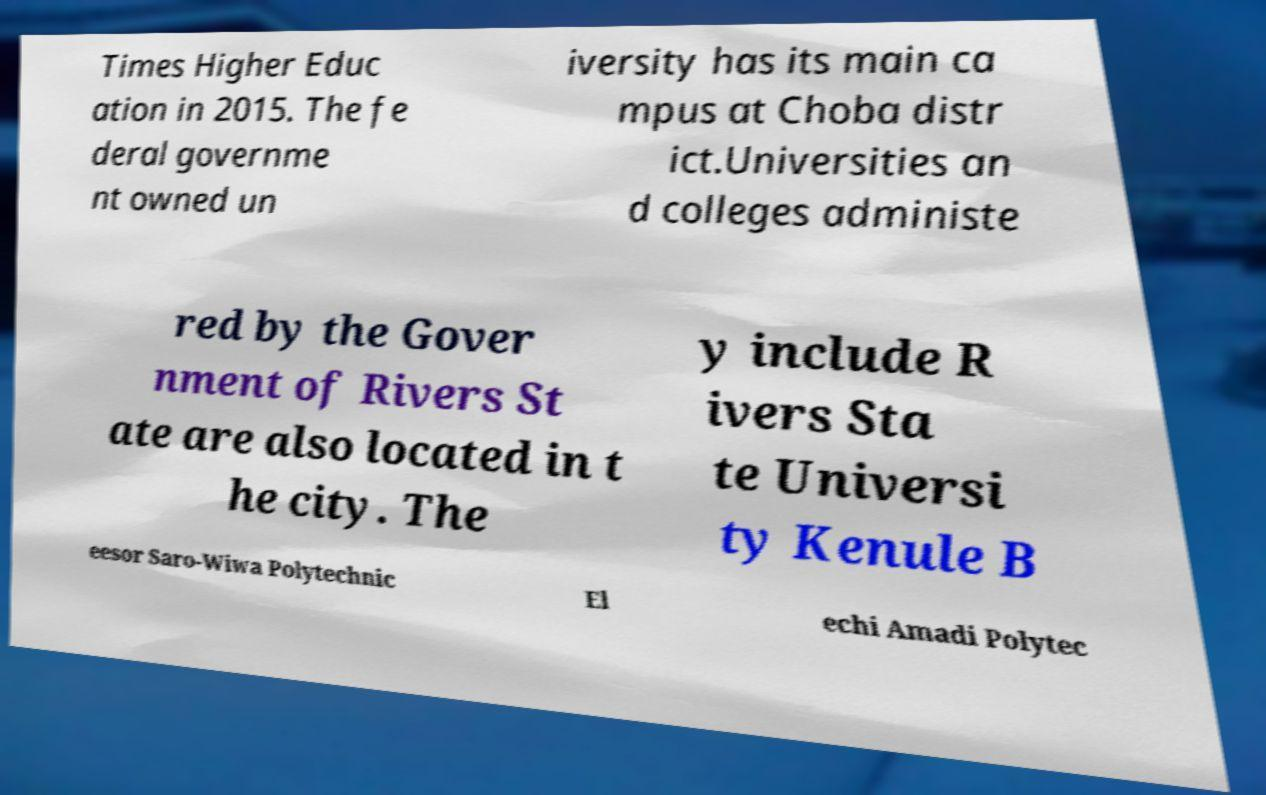Please read and relay the text visible in this image. What does it say? Times Higher Educ ation in 2015. The fe deral governme nt owned un iversity has its main ca mpus at Choba distr ict.Universities an d colleges administe red by the Gover nment of Rivers St ate are also located in t he city. The y include R ivers Sta te Universi ty Kenule B eesor Saro-Wiwa Polytechnic El echi Amadi Polytec 